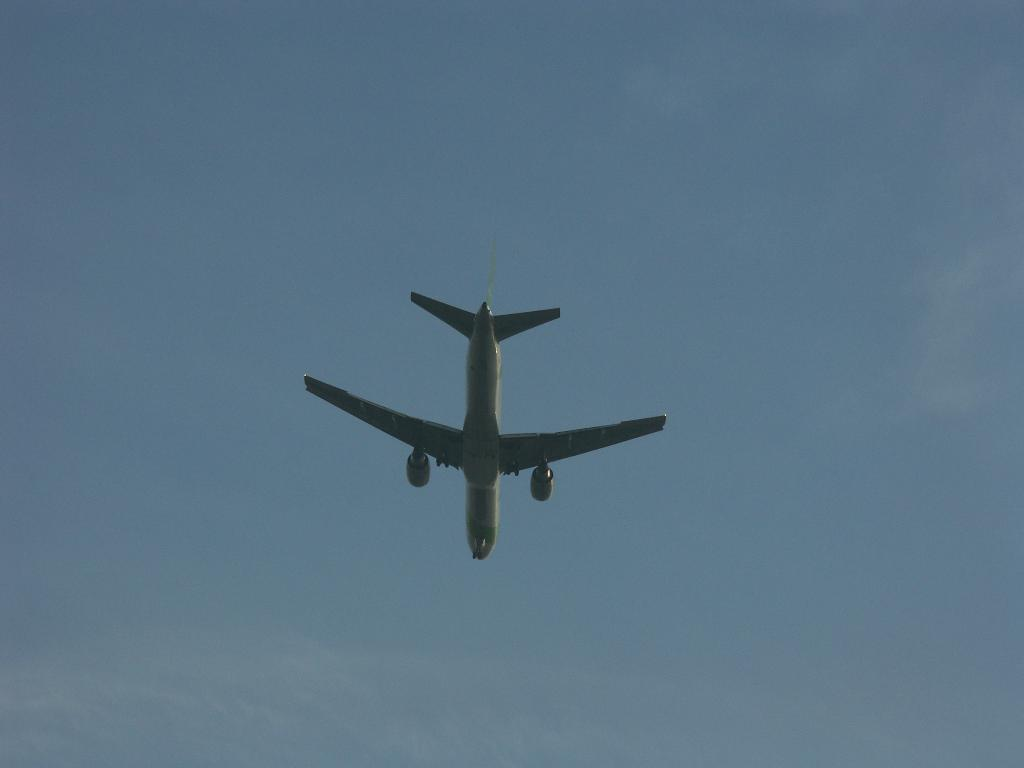What is the main subject of the picture? The main subject of the picture is an airplane. What is the airplane doing in the image? The airplane is flying in the air. What can be seen in the background of the image? The sky is visible in the background of the image. Can you see any yaks grazing in the image? There are no yaks present in the image; it features an airplane flying in the sky. What type of curve is visible in the image? There is no curve visible in the image; it shows an airplane flying in the sky against a backdrop of the sky. 